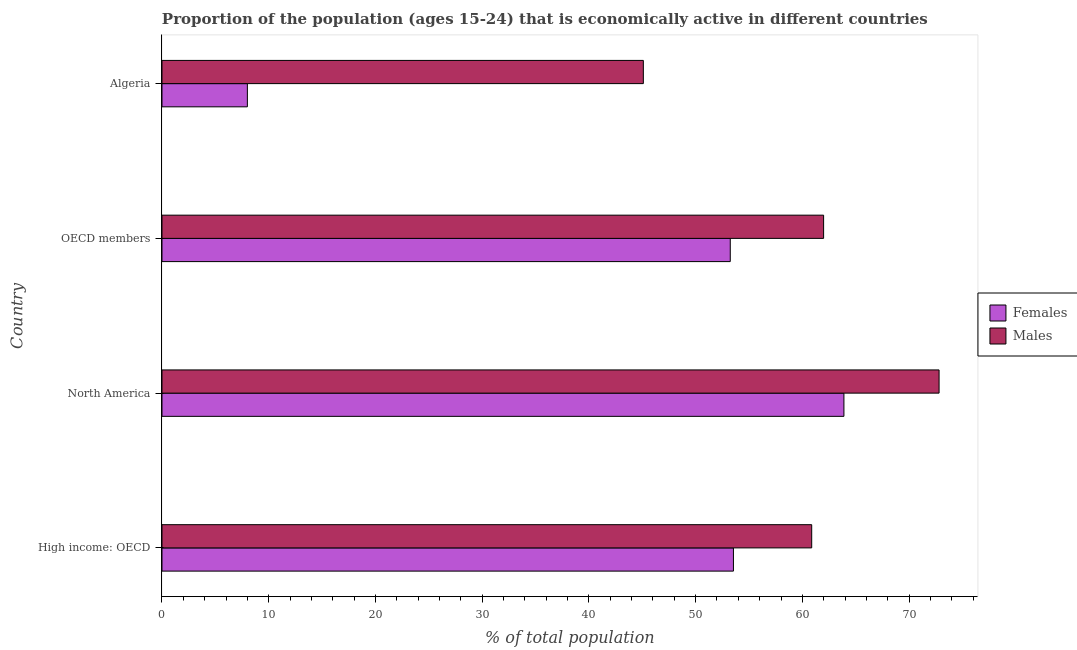How many different coloured bars are there?
Keep it short and to the point. 2. How many groups of bars are there?
Your response must be concise. 4. Are the number of bars per tick equal to the number of legend labels?
Your answer should be compact. Yes. Are the number of bars on each tick of the Y-axis equal?
Your response must be concise. Yes. How many bars are there on the 2nd tick from the bottom?
Keep it short and to the point. 2. What is the label of the 2nd group of bars from the top?
Ensure brevity in your answer.  OECD members. In how many cases, is the number of bars for a given country not equal to the number of legend labels?
Offer a terse response. 0. What is the percentage of economically active male population in OECD members?
Provide a short and direct response. 61.99. Across all countries, what is the maximum percentage of economically active female population?
Your answer should be compact. 63.89. Across all countries, what is the minimum percentage of economically active male population?
Offer a terse response. 45.1. In which country was the percentage of economically active male population minimum?
Keep it short and to the point. Algeria. What is the total percentage of economically active male population in the graph?
Provide a succinct answer. 240.77. What is the difference between the percentage of economically active female population in North America and that in OECD members?
Offer a very short reply. 10.65. What is the difference between the percentage of economically active male population in OECD members and the percentage of economically active female population in Algeria?
Give a very brief answer. 53.99. What is the average percentage of economically active male population per country?
Offer a terse response. 60.19. What is the difference between the percentage of economically active male population and percentage of economically active female population in Algeria?
Offer a very short reply. 37.1. In how many countries, is the percentage of economically active female population greater than 10 %?
Provide a succinct answer. 3. What is the ratio of the percentage of economically active male population in Algeria to that in North America?
Your answer should be compact. 0.62. What is the difference between the highest and the second highest percentage of economically active male population?
Your answer should be very brief. 10.82. What is the difference between the highest and the lowest percentage of economically active male population?
Make the answer very short. 27.71. Is the sum of the percentage of economically active male population in Algeria and North America greater than the maximum percentage of economically active female population across all countries?
Offer a very short reply. Yes. What does the 1st bar from the top in High income: OECD represents?
Your answer should be compact. Males. What does the 1st bar from the bottom in North America represents?
Make the answer very short. Females. How many bars are there?
Offer a very short reply. 8. Are all the bars in the graph horizontal?
Provide a succinct answer. Yes. How many countries are there in the graph?
Your answer should be very brief. 4. What is the difference between two consecutive major ticks on the X-axis?
Make the answer very short. 10. Are the values on the major ticks of X-axis written in scientific E-notation?
Ensure brevity in your answer.  No. Where does the legend appear in the graph?
Your answer should be very brief. Center right. What is the title of the graph?
Keep it short and to the point. Proportion of the population (ages 15-24) that is economically active in different countries. Does "Old" appear as one of the legend labels in the graph?
Give a very brief answer. No. What is the label or title of the X-axis?
Your answer should be very brief. % of total population. What is the % of total population in Females in High income: OECD?
Your response must be concise. 53.54. What is the % of total population in Males in High income: OECD?
Your response must be concise. 60.87. What is the % of total population of Females in North America?
Your answer should be compact. 63.89. What is the % of total population in Males in North America?
Your answer should be compact. 72.81. What is the % of total population in Females in OECD members?
Offer a terse response. 53.24. What is the % of total population of Males in OECD members?
Keep it short and to the point. 61.99. What is the % of total population in Females in Algeria?
Offer a very short reply. 8. What is the % of total population in Males in Algeria?
Your response must be concise. 45.1. Across all countries, what is the maximum % of total population in Females?
Ensure brevity in your answer.  63.89. Across all countries, what is the maximum % of total population in Males?
Make the answer very short. 72.81. Across all countries, what is the minimum % of total population in Females?
Provide a succinct answer. 8. Across all countries, what is the minimum % of total population of Males?
Ensure brevity in your answer.  45.1. What is the total % of total population in Females in the graph?
Give a very brief answer. 178.68. What is the total % of total population of Males in the graph?
Keep it short and to the point. 240.77. What is the difference between the % of total population in Females in High income: OECD and that in North America?
Your answer should be very brief. -10.35. What is the difference between the % of total population in Males in High income: OECD and that in North America?
Your answer should be compact. -11.93. What is the difference between the % of total population of Females in High income: OECD and that in OECD members?
Make the answer very short. 0.3. What is the difference between the % of total population in Males in High income: OECD and that in OECD members?
Make the answer very short. -1.12. What is the difference between the % of total population in Females in High income: OECD and that in Algeria?
Your answer should be very brief. 45.54. What is the difference between the % of total population in Males in High income: OECD and that in Algeria?
Your response must be concise. 15.77. What is the difference between the % of total population of Females in North America and that in OECD members?
Provide a short and direct response. 10.65. What is the difference between the % of total population of Males in North America and that in OECD members?
Your answer should be very brief. 10.82. What is the difference between the % of total population of Females in North America and that in Algeria?
Your answer should be compact. 55.89. What is the difference between the % of total population of Males in North America and that in Algeria?
Offer a terse response. 27.71. What is the difference between the % of total population of Females in OECD members and that in Algeria?
Your response must be concise. 45.24. What is the difference between the % of total population of Males in OECD members and that in Algeria?
Your answer should be compact. 16.89. What is the difference between the % of total population of Females in High income: OECD and the % of total population of Males in North America?
Ensure brevity in your answer.  -19.27. What is the difference between the % of total population in Females in High income: OECD and the % of total population in Males in OECD members?
Offer a terse response. -8.45. What is the difference between the % of total population in Females in High income: OECD and the % of total population in Males in Algeria?
Provide a succinct answer. 8.44. What is the difference between the % of total population of Females in North America and the % of total population of Males in OECD members?
Provide a succinct answer. 1.9. What is the difference between the % of total population of Females in North America and the % of total population of Males in Algeria?
Your answer should be compact. 18.79. What is the difference between the % of total population of Females in OECD members and the % of total population of Males in Algeria?
Offer a very short reply. 8.14. What is the average % of total population in Females per country?
Your response must be concise. 44.67. What is the average % of total population in Males per country?
Make the answer very short. 60.19. What is the difference between the % of total population in Females and % of total population in Males in High income: OECD?
Offer a terse response. -7.33. What is the difference between the % of total population in Females and % of total population in Males in North America?
Your answer should be very brief. -8.91. What is the difference between the % of total population of Females and % of total population of Males in OECD members?
Offer a very short reply. -8.75. What is the difference between the % of total population of Females and % of total population of Males in Algeria?
Offer a terse response. -37.1. What is the ratio of the % of total population in Females in High income: OECD to that in North America?
Keep it short and to the point. 0.84. What is the ratio of the % of total population in Males in High income: OECD to that in North America?
Provide a short and direct response. 0.84. What is the ratio of the % of total population in Females in High income: OECD to that in OECD members?
Your answer should be very brief. 1.01. What is the ratio of the % of total population of Males in High income: OECD to that in OECD members?
Your response must be concise. 0.98. What is the ratio of the % of total population of Females in High income: OECD to that in Algeria?
Your answer should be compact. 6.69. What is the ratio of the % of total population of Males in High income: OECD to that in Algeria?
Your response must be concise. 1.35. What is the ratio of the % of total population in Females in North America to that in OECD members?
Offer a very short reply. 1.2. What is the ratio of the % of total population in Males in North America to that in OECD members?
Offer a very short reply. 1.17. What is the ratio of the % of total population in Females in North America to that in Algeria?
Offer a terse response. 7.99. What is the ratio of the % of total population of Males in North America to that in Algeria?
Keep it short and to the point. 1.61. What is the ratio of the % of total population in Females in OECD members to that in Algeria?
Provide a succinct answer. 6.66. What is the ratio of the % of total population in Males in OECD members to that in Algeria?
Offer a terse response. 1.37. What is the difference between the highest and the second highest % of total population in Females?
Ensure brevity in your answer.  10.35. What is the difference between the highest and the second highest % of total population of Males?
Your response must be concise. 10.82. What is the difference between the highest and the lowest % of total population of Females?
Your answer should be very brief. 55.89. What is the difference between the highest and the lowest % of total population of Males?
Provide a short and direct response. 27.71. 